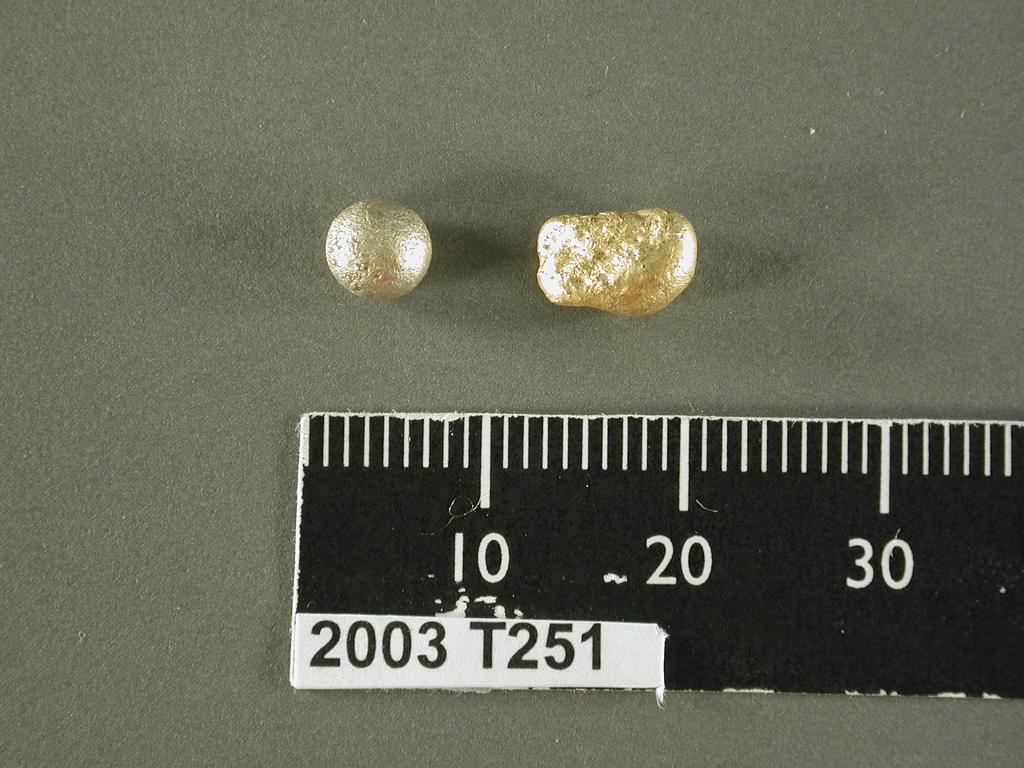What is the serial number?
Offer a very short reply. 2003 t251. 